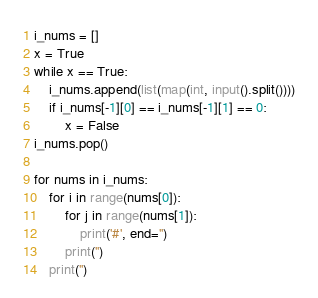<code> <loc_0><loc_0><loc_500><loc_500><_Python_>i_nums = []
x = True
while x == True:
    i_nums.append(list(map(int, input().split())))
    if i_nums[-1][0] == i_nums[-1][1] == 0:
        x = False
i_nums.pop()

for nums in i_nums:
    for i in range(nums[0]):
        for j in range(nums[1]):
            print('#', end='')
        print('')
    print('')
</code> 